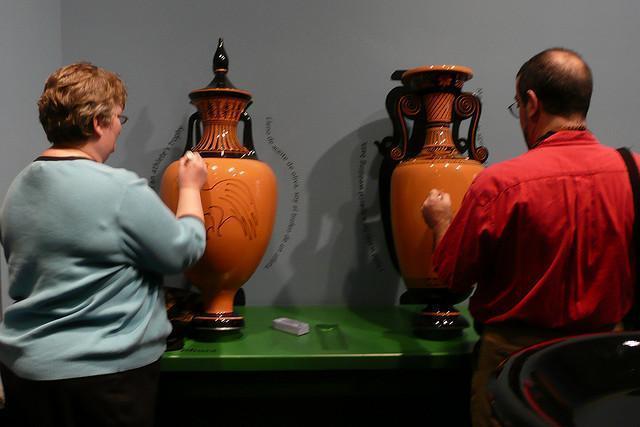What is the woman drawing?
Select the accurate answer and provide justification: `Answer: choice
Rationale: srationale.`
Options: Pigeon, camel, peacock, rooster. Answer: rooster.
Rationale: The outline of the woman's drawing appears to have the features, feather pattern and general shape of answer a. 